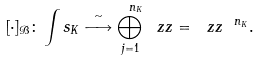Convert formula to latex. <formula><loc_0><loc_0><loc_500><loc_500>[ \cdot ] _ { \mathcal { B } } \colon \int s _ { K } \stackrel { \sim } { \longrightarrow } \bigoplus _ { j = 1 } ^ { \ n _ { K } } \ z z = \ z z ^ { \ n _ { K } } .</formula> 